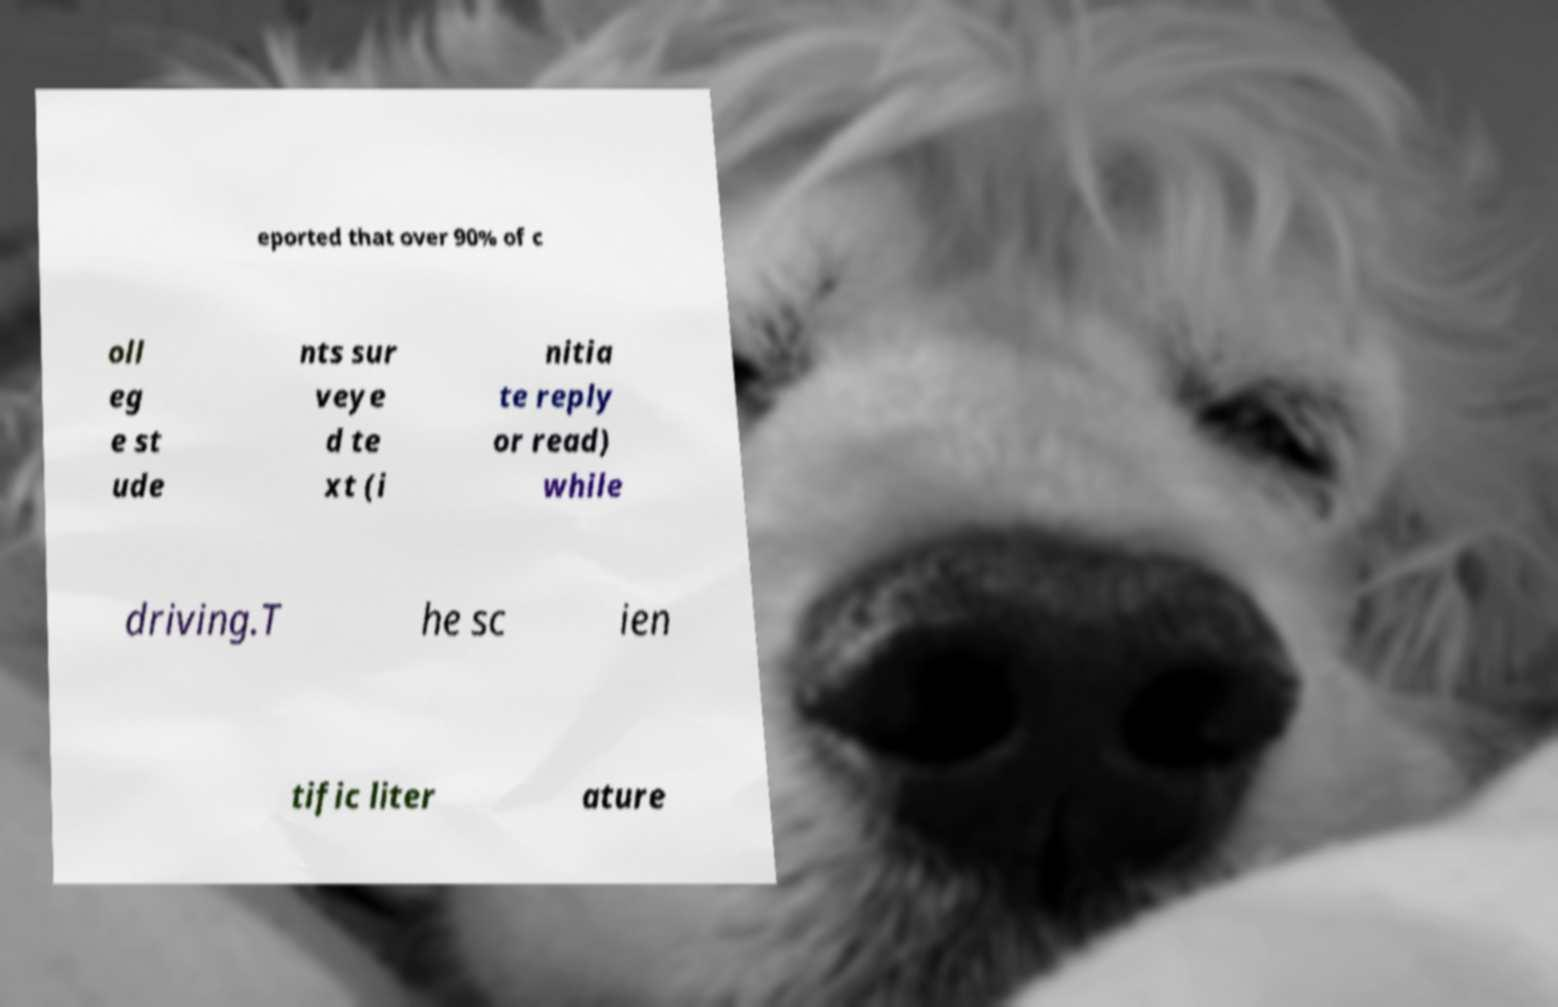I need the written content from this picture converted into text. Can you do that? eported that over 90% of c oll eg e st ude nts sur veye d te xt (i nitia te reply or read) while driving.T he sc ien tific liter ature 